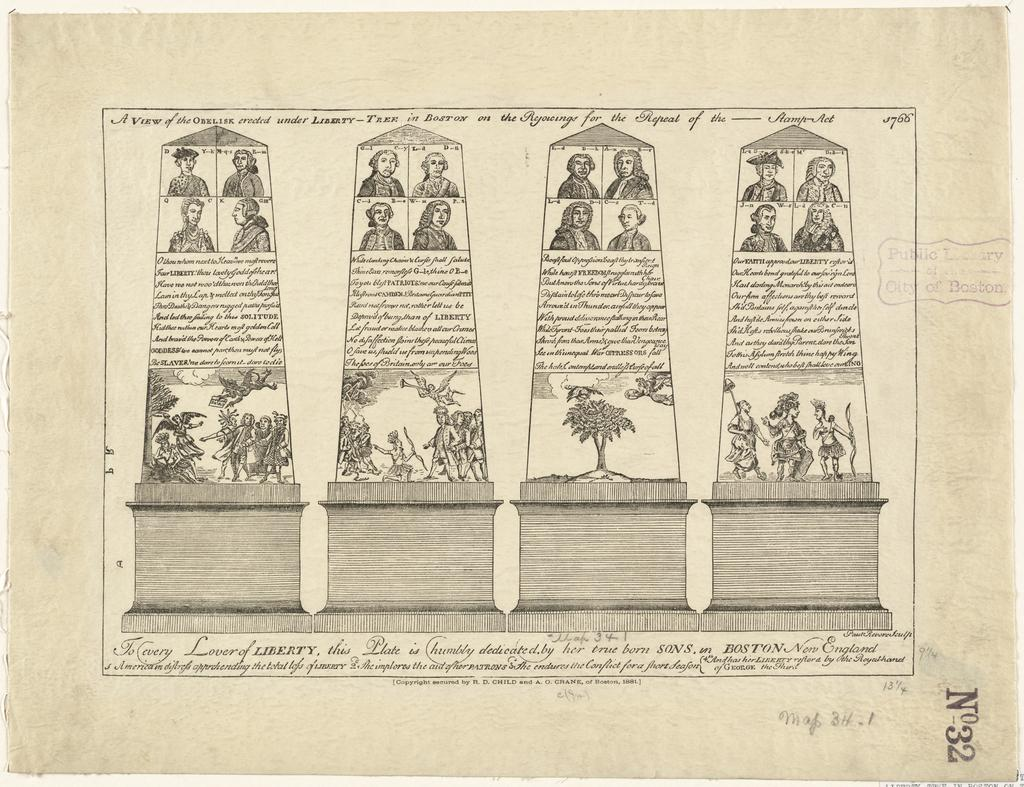What is depicted on the paper in the image? There are drawings on a paper in the image. What type of text is present on the paper in the image? There are handwritten words in the image. What sound does the pin make when it hits the bell in the image? There is no pin or bell present in the image; it only features drawings and handwritten words on a paper. 